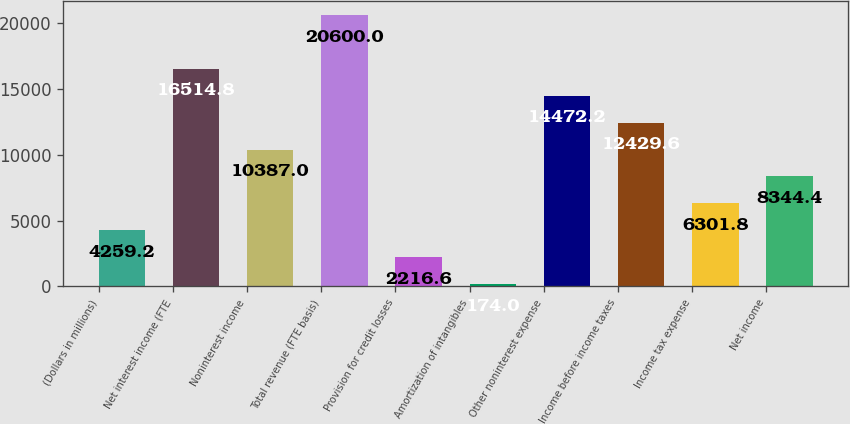Convert chart. <chart><loc_0><loc_0><loc_500><loc_500><bar_chart><fcel>(Dollars in millions)<fcel>Net interest income (FTE<fcel>Noninterest income<fcel>Total revenue (FTE basis)<fcel>Provision for credit losses<fcel>Amortization of intangibles<fcel>Other noninterest expense<fcel>Income before income taxes<fcel>Income tax expense<fcel>Net income<nl><fcel>4259.2<fcel>16514.8<fcel>10387<fcel>20600<fcel>2216.6<fcel>174<fcel>14472.2<fcel>12429.6<fcel>6301.8<fcel>8344.4<nl></chart> 